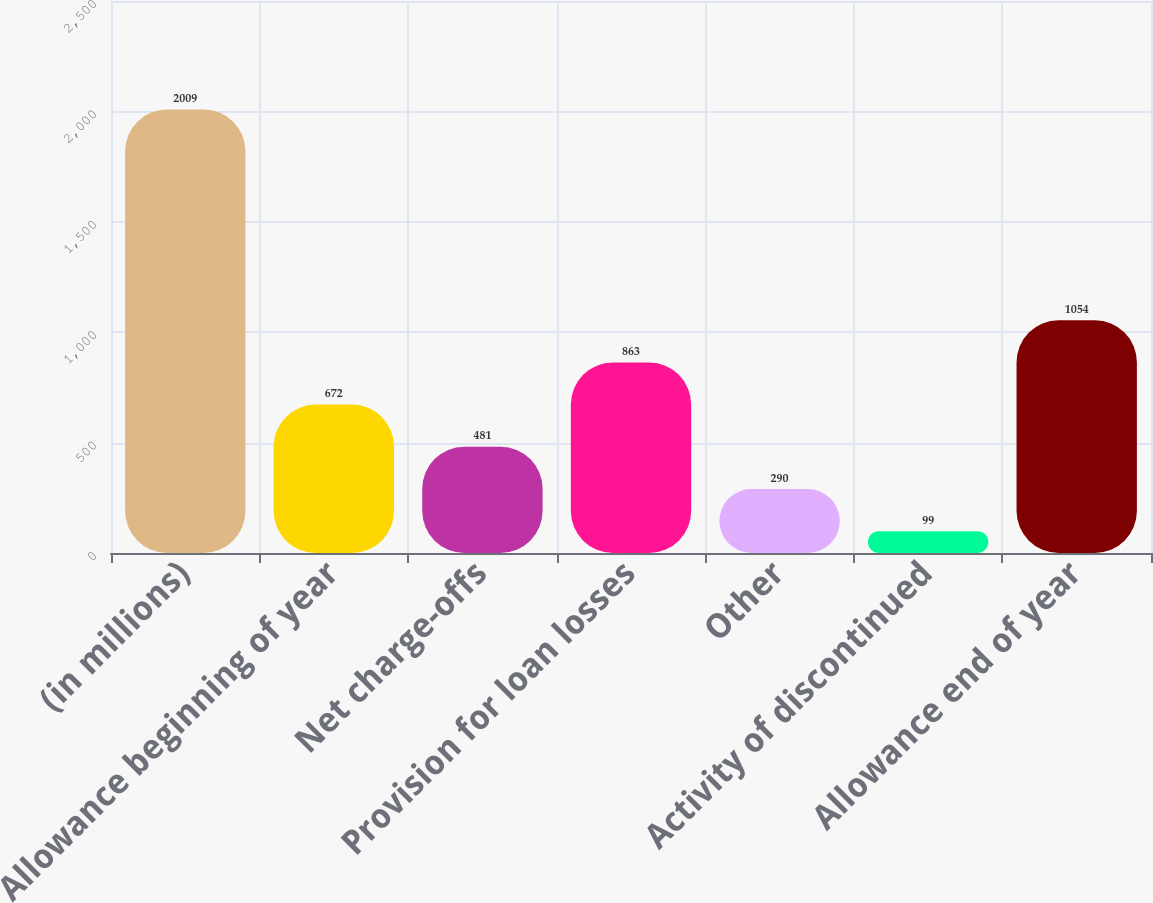Convert chart. <chart><loc_0><loc_0><loc_500><loc_500><bar_chart><fcel>(in millions)<fcel>Allowance beginning of year<fcel>Net charge-offs<fcel>Provision for loan losses<fcel>Other<fcel>Activity of discontinued<fcel>Allowance end of year<nl><fcel>2009<fcel>672<fcel>481<fcel>863<fcel>290<fcel>99<fcel>1054<nl></chart> 